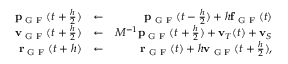Convert formula to latex. <formula><loc_0><loc_0><loc_500><loc_500>\begin{array} { r l r } { { p } _ { G F } ( t + \frac { h } { 2 } ) } & { \leftarrow } & { { p } _ { G F } ( t - \frac { h } { 2 } ) + h { f } _ { G F } ( t ) } \\ { { v } _ { G F } ( t + \frac { h } { 2 } ) } & { \leftarrow } & { M ^ { - 1 } { p } _ { G F } ( t + \frac { h } { 2 } ) + { v } _ { T } ( t ) + { v } _ { S } } \\ { { r } _ { G F } ( t + h ) } & { \leftarrow } & { { r } _ { G F } ( t ) + h { v } _ { G F } ( t + \frac { h } { 2 } ) , } \end{array}</formula> 